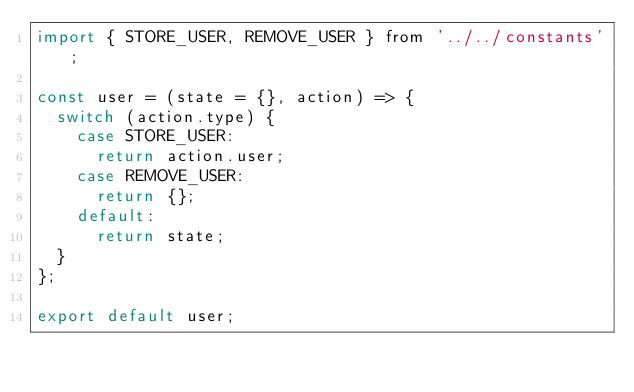Convert code to text. <code><loc_0><loc_0><loc_500><loc_500><_JavaScript_>import { STORE_USER, REMOVE_USER } from '../../constants';

const user = (state = {}, action) => {
  switch (action.type) {
    case STORE_USER:
      return action.user;
    case REMOVE_USER:
      return {};
    default:
      return state;
  }
};

export default user;
</code> 